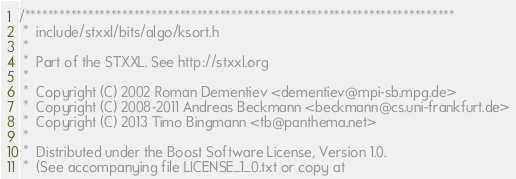<code> <loc_0><loc_0><loc_500><loc_500><_C_>/***************************************************************************
 *  include/stxxl/bits/algo/ksort.h
 *
 *  Part of the STXXL. See http://stxxl.org
 *
 *  Copyright (C) 2002 Roman Dementiev <dementiev@mpi-sb.mpg.de>
 *  Copyright (C) 2008-2011 Andreas Beckmann <beckmann@cs.uni-frankfurt.de>
 *  Copyright (C) 2013 Timo Bingmann <tb@panthema.net>
 *
 *  Distributed under the Boost Software License, Version 1.0.
 *  (See accompanying file LICENSE_1_0.txt or copy at</code> 